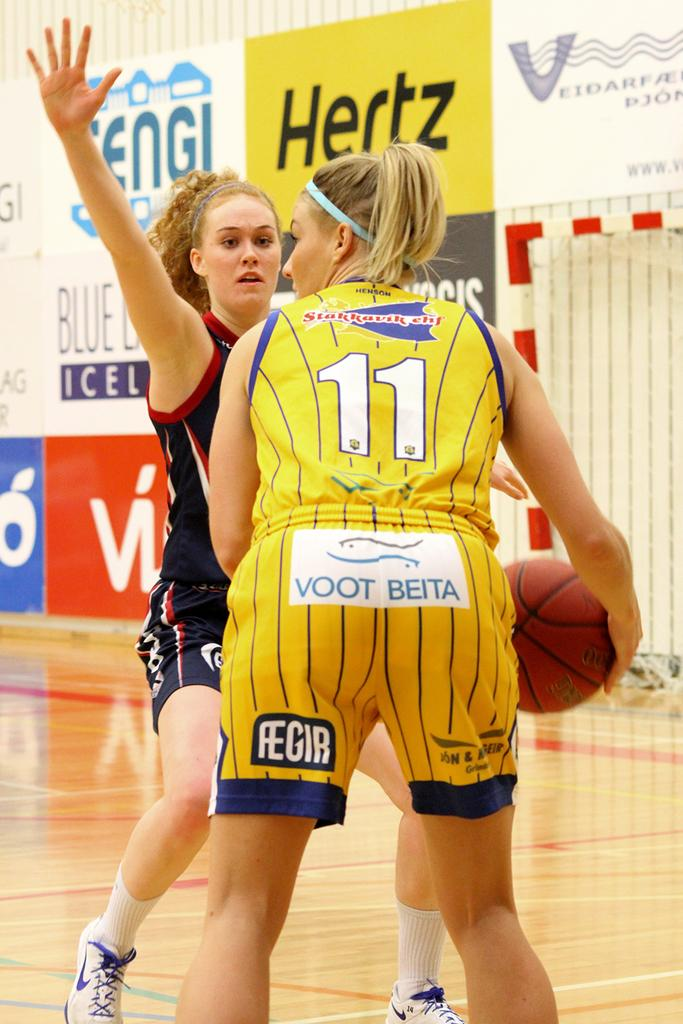<image>
Offer a succinct explanation of the picture presented. A girl playing basketball has the number 11 on the back of her shirt. 